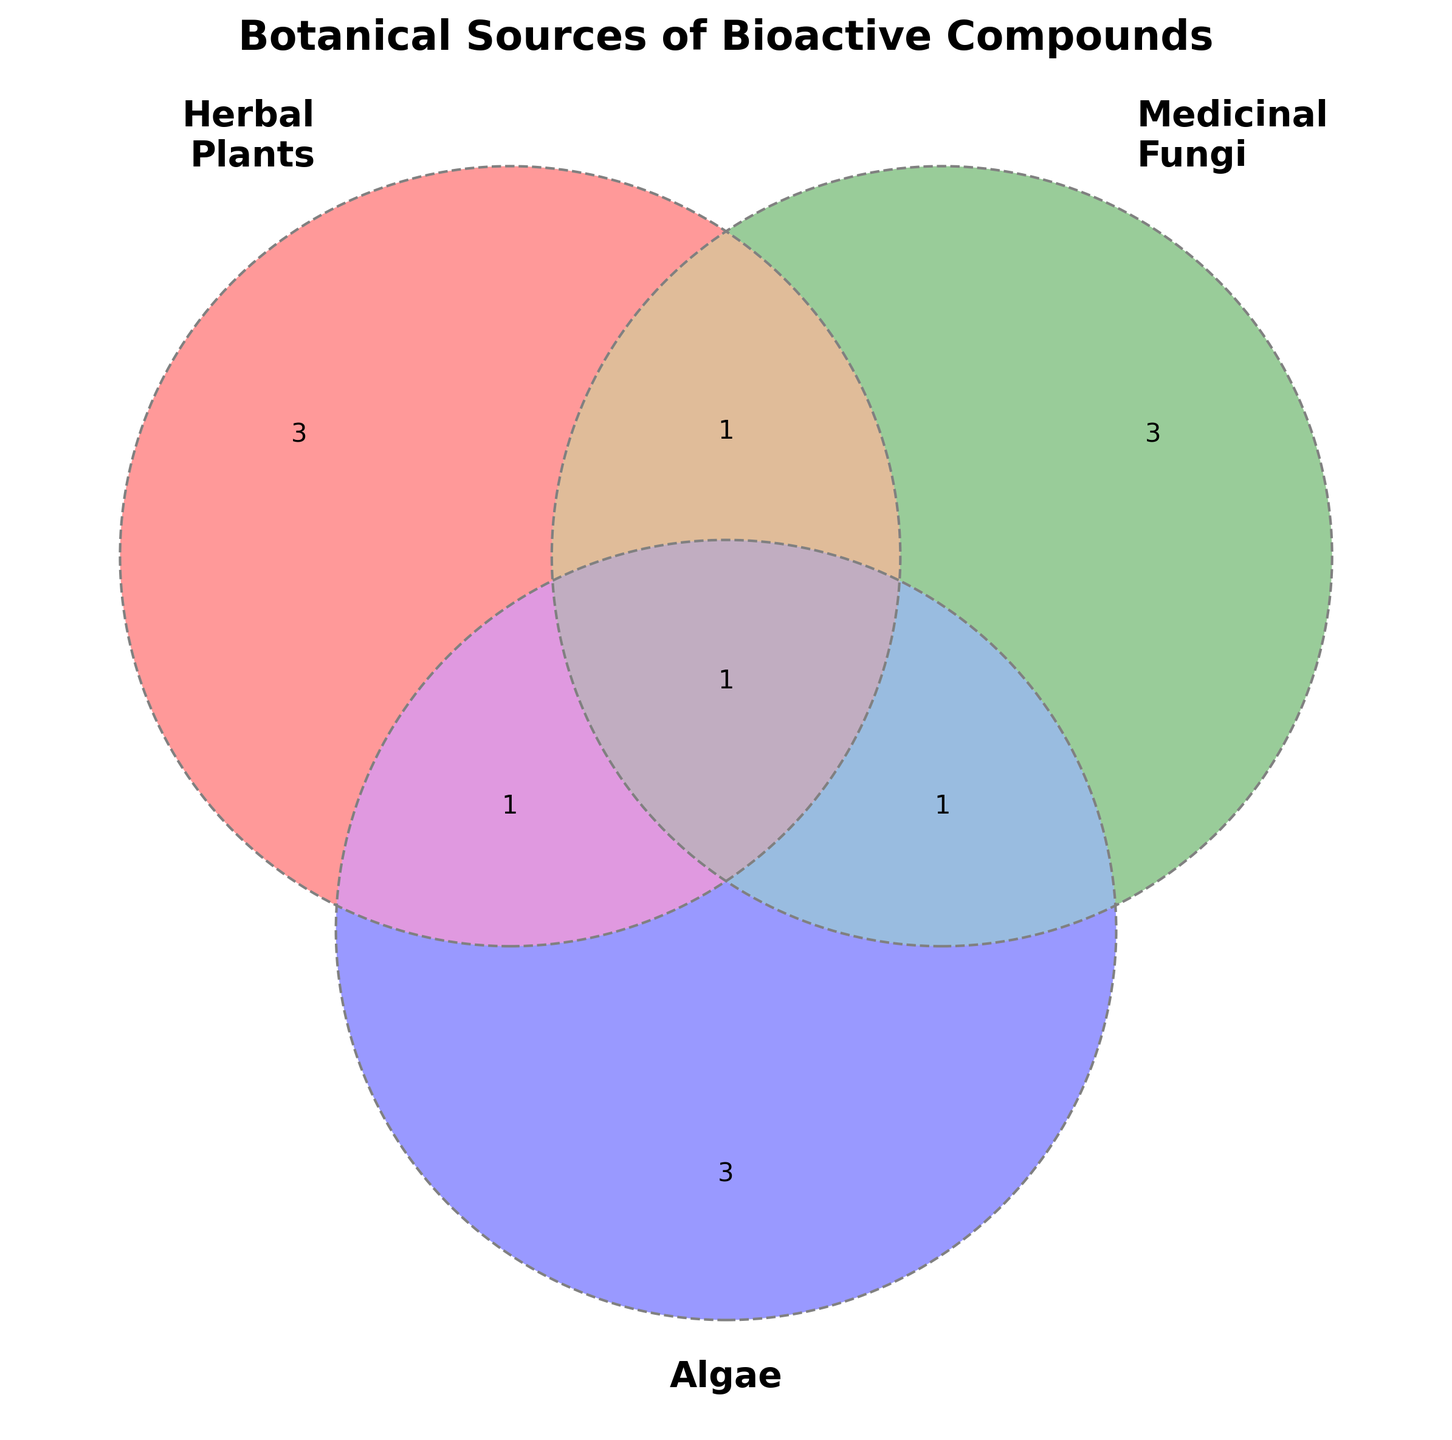What bioactive compounds are unique to Algae? Identify the region in the Venn diagram that represents Algae only (not intersecting with other sets). The compounds in this region are: Fucoxanthin, Astaxanthin, Phycobiliproteins.
Answer: Fucoxanthin, Astaxanthin, Phycobiliproteins Which compound categories are common to Herbal Plants and Medicinal Fungi? Look at the intersection between Herbal Plants and Medicinal Fungi, excluding Algae. The compound here is Polyphenols.
Answer: Polyphenols Are there any compounds shared by all three sources? Identify the region where all three sets intersect. The compound in this region is Antioxidants.
Answer: Antioxidants What bioactive compounds are found in Herbal Plants but not in other categories? Look at the unique section of the Venn diagram for Herbal Plants. The compounds are Ginsenosides, Curcuminoids, and Flavonoids.
Answer: Ginsenosides, Curcuminoids, Flavonoids Which bioactive compounds are found in both Algae and Medicinal Fungi but not in Herbal Plants? Find the intersection between Algae and Medicinal Fungi that doesn't overlap with Herbal Plants. The compound is Omega-3 fatty acids.
Answer: Omega-3 fatty acids What is the total number of unique bioactive compounds in Medicinal Fungi? Sum all unique compounds in Medicinal Fungi, including those shared with other categories. Beta-glucans, Triterpenoids, Polysaccharides, Polyphenols, Omega-3 fatty acids, Antioxidants. This totals 6 compounds.
Answer: 6 How many bioactive compounds are shared between Herbal Plants and Algae? Identify the intersection between Herbal Plants and Algae. The compound here is Carotenoids.
Answer: Carotenoids Which category has the most unique bioactive compounds? Count the unique compounds in each category: Herbal Plants (3), Medicinal Fungi (3), Algae (3). Each has an equal number of unique compounds - 3.
Answer: Herbal Plants, Medicinal Fungi, Algae (each 3) What's the Venn diagram title? Look at the title placed at the top of the Venn diagram. The title is "Botanical Sources of Bioactive Compounds."
Answer: Botanical Sources of Bioactive Compounds 